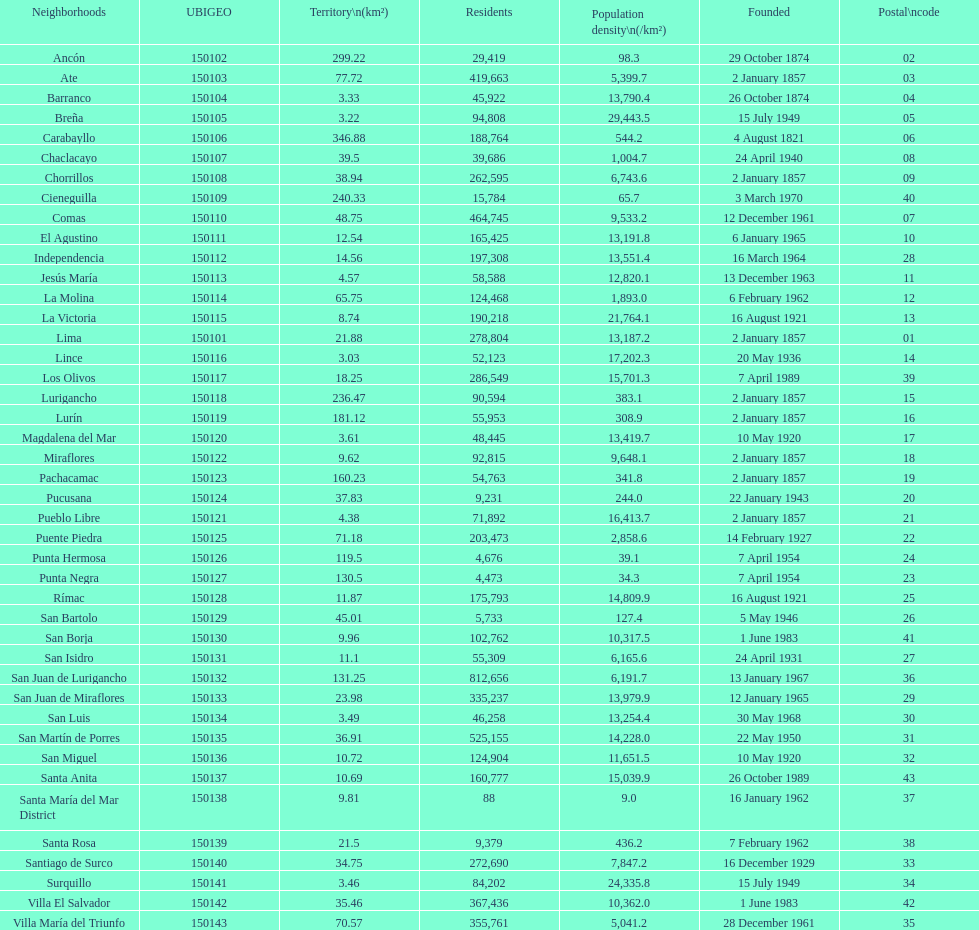Write the full table. {'header': ['Neighborhoods', 'UBIGEO', 'Territory\\n(km²)', 'Residents', 'Population density\\n(/km²)', 'Founded', 'Postal\\ncode'], 'rows': [['Ancón', '150102', '299.22', '29,419', '98.3', '29 October 1874', '02'], ['Ate', '150103', '77.72', '419,663', '5,399.7', '2 January 1857', '03'], ['Barranco', '150104', '3.33', '45,922', '13,790.4', '26 October 1874', '04'], ['Breña', '150105', '3.22', '94,808', '29,443.5', '15 July 1949', '05'], ['Carabayllo', '150106', '346.88', '188,764', '544.2', '4 August 1821', '06'], ['Chaclacayo', '150107', '39.5', '39,686', '1,004.7', '24 April 1940', '08'], ['Chorrillos', '150108', '38.94', '262,595', '6,743.6', '2 January 1857', '09'], ['Cieneguilla', '150109', '240.33', '15,784', '65.7', '3 March 1970', '40'], ['Comas', '150110', '48.75', '464,745', '9,533.2', '12 December 1961', '07'], ['El Agustino', '150111', '12.54', '165,425', '13,191.8', '6 January 1965', '10'], ['Independencia', '150112', '14.56', '197,308', '13,551.4', '16 March 1964', '28'], ['Jesús María', '150113', '4.57', '58,588', '12,820.1', '13 December 1963', '11'], ['La Molina', '150114', '65.75', '124,468', '1,893.0', '6 February 1962', '12'], ['La Victoria', '150115', '8.74', '190,218', '21,764.1', '16 August 1921', '13'], ['Lima', '150101', '21.88', '278,804', '13,187.2', '2 January 1857', '01'], ['Lince', '150116', '3.03', '52,123', '17,202.3', '20 May 1936', '14'], ['Los Olivos', '150117', '18.25', '286,549', '15,701.3', '7 April 1989', '39'], ['Lurigancho', '150118', '236.47', '90,594', '383.1', '2 January 1857', '15'], ['Lurín', '150119', '181.12', '55,953', '308.9', '2 January 1857', '16'], ['Magdalena del Mar', '150120', '3.61', '48,445', '13,419.7', '10 May 1920', '17'], ['Miraflores', '150122', '9.62', '92,815', '9,648.1', '2 January 1857', '18'], ['Pachacamac', '150123', '160.23', '54,763', '341.8', '2 January 1857', '19'], ['Pucusana', '150124', '37.83', '9,231', '244.0', '22 January 1943', '20'], ['Pueblo Libre', '150121', '4.38', '71,892', '16,413.7', '2 January 1857', '21'], ['Puente Piedra', '150125', '71.18', '203,473', '2,858.6', '14 February 1927', '22'], ['Punta Hermosa', '150126', '119.5', '4,676', '39.1', '7 April 1954', '24'], ['Punta Negra', '150127', '130.5', '4,473', '34.3', '7 April 1954', '23'], ['Rímac', '150128', '11.87', '175,793', '14,809.9', '16 August 1921', '25'], ['San Bartolo', '150129', '45.01', '5,733', '127.4', '5 May 1946', '26'], ['San Borja', '150130', '9.96', '102,762', '10,317.5', '1 June 1983', '41'], ['San Isidro', '150131', '11.1', '55,309', '6,165.6', '24 April 1931', '27'], ['San Juan de Lurigancho', '150132', '131.25', '812,656', '6,191.7', '13 January 1967', '36'], ['San Juan de Miraflores', '150133', '23.98', '335,237', '13,979.9', '12 January 1965', '29'], ['San Luis', '150134', '3.49', '46,258', '13,254.4', '30 May 1968', '30'], ['San Martín de Porres', '150135', '36.91', '525,155', '14,228.0', '22 May 1950', '31'], ['San Miguel', '150136', '10.72', '124,904', '11,651.5', '10 May 1920', '32'], ['Santa Anita', '150137', '10.69', '160,777', '15,039.9', '26 October 1989', '43'], ['Santa María del Mar District', '150138', '9.81', '88', '9.0', '16 January 1962', '37'], ['Santa Rosa', '150139', '21.5', '9,379', '436.2', '7 February 1962', '38'], ['Santiago de Surco', '150140', '34.75', '272,690', '7,847.2', '16 December 1929', '33'], ['Surquillo', '150141', '3.46', '84,202', '24,335.8', '15 July 1949', '34'], ['Villa El Salvador', '150142', '35.46', '367,436', '10,362.0', '1 June 1983', '42'], ['Villa María del Triunfo', '150143', '70.57', '355,761', '5,041.2', '28 December 1961', '35']]} Which is the largest district in terms of population? San Juan de Lurigancho. 